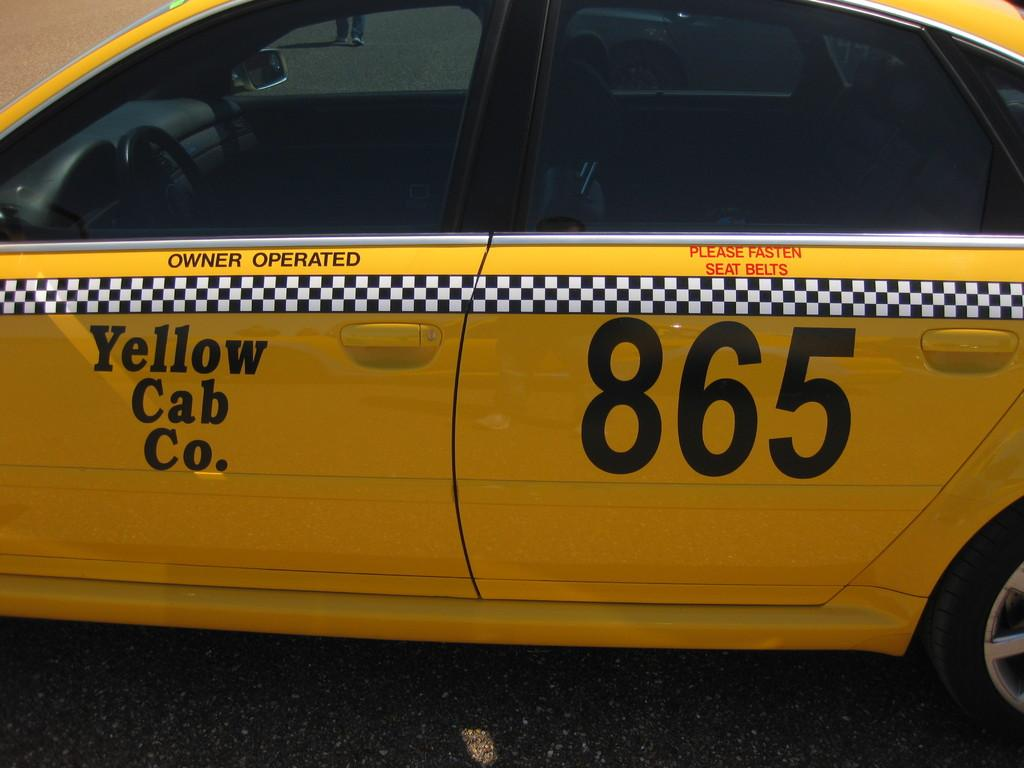<image>
Give a short and clear explanation of the subsequent image. An owner operated Yellow cab's midsection and number 865 